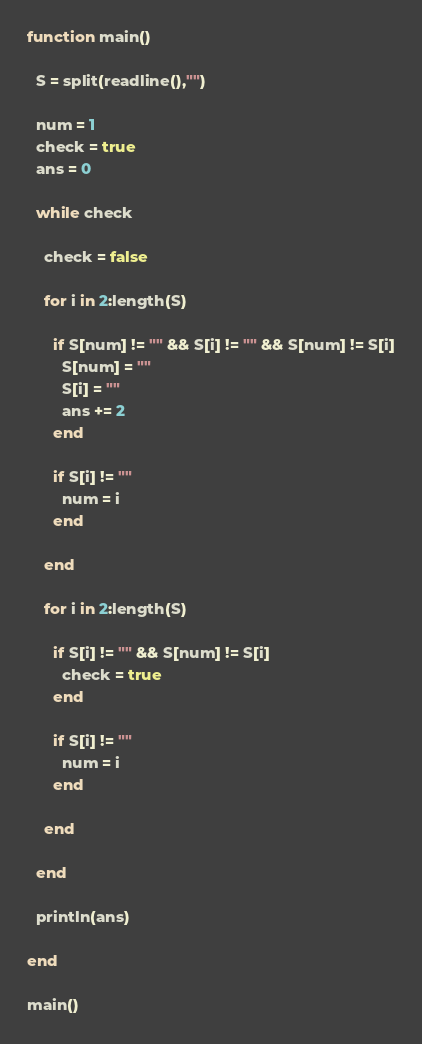<code> <loc_0><loc_0><loc_500><loc_500><_Julia_>function main()
  
  S = split(readline(),"")
  
  num = 1
  check = true
  ans = 0
  
  while check
    
    check = false
    
	for i in 2:length(S)

      if S[num] != "" && S[i] != "" && S[num] != S[i]
        S[num] = ""
        S[i] = ""
        ans += 2
      end
    
      if S[i] != ""
        num = i
      end
      
    end

    for i in 2:length(S)
      
      if S[i] != "" && S[num] != S[i]
        check = true
      end
    
      if S[i] != ""
        num = i
      end

    end
    
  end

  println(ans)
  
end

main()</code> 